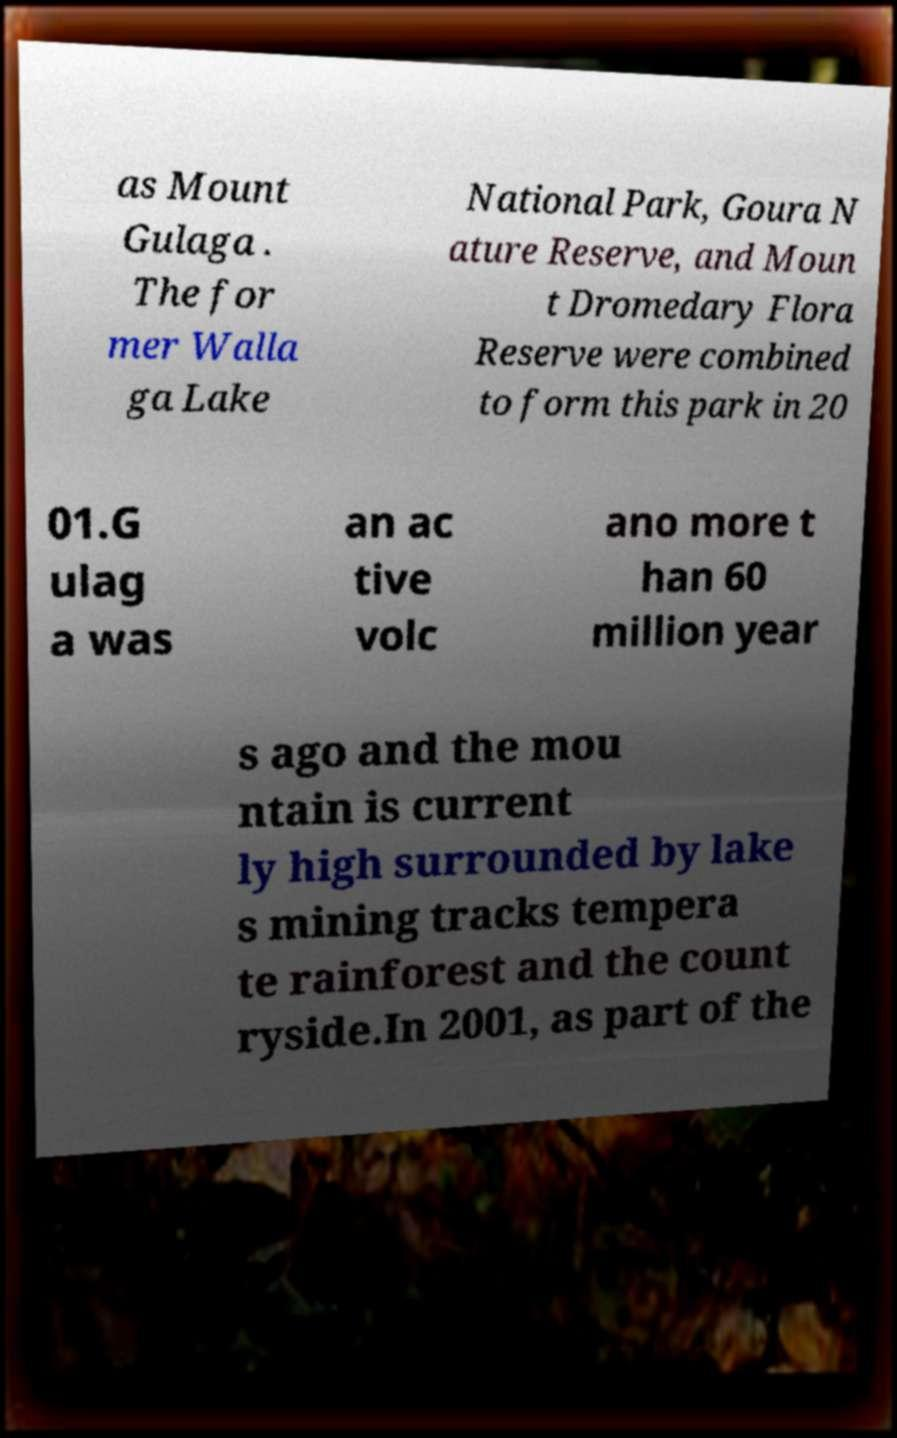Can you accurately transcribe the text from the provided image for me? as Mount Gulaga . The for mer Walla ga Lake National Park, Goura N ature Reserve, and Moun t Dromedary Flora Reserve were combined to form this park in 20 01.G ulag a was an ac tive volc ano more t han 60 million year s ago and the mou ntain is current ly high surrounded by lake s mining tracks tempera te rainforest and the count ryside.In 2001, as part of the 